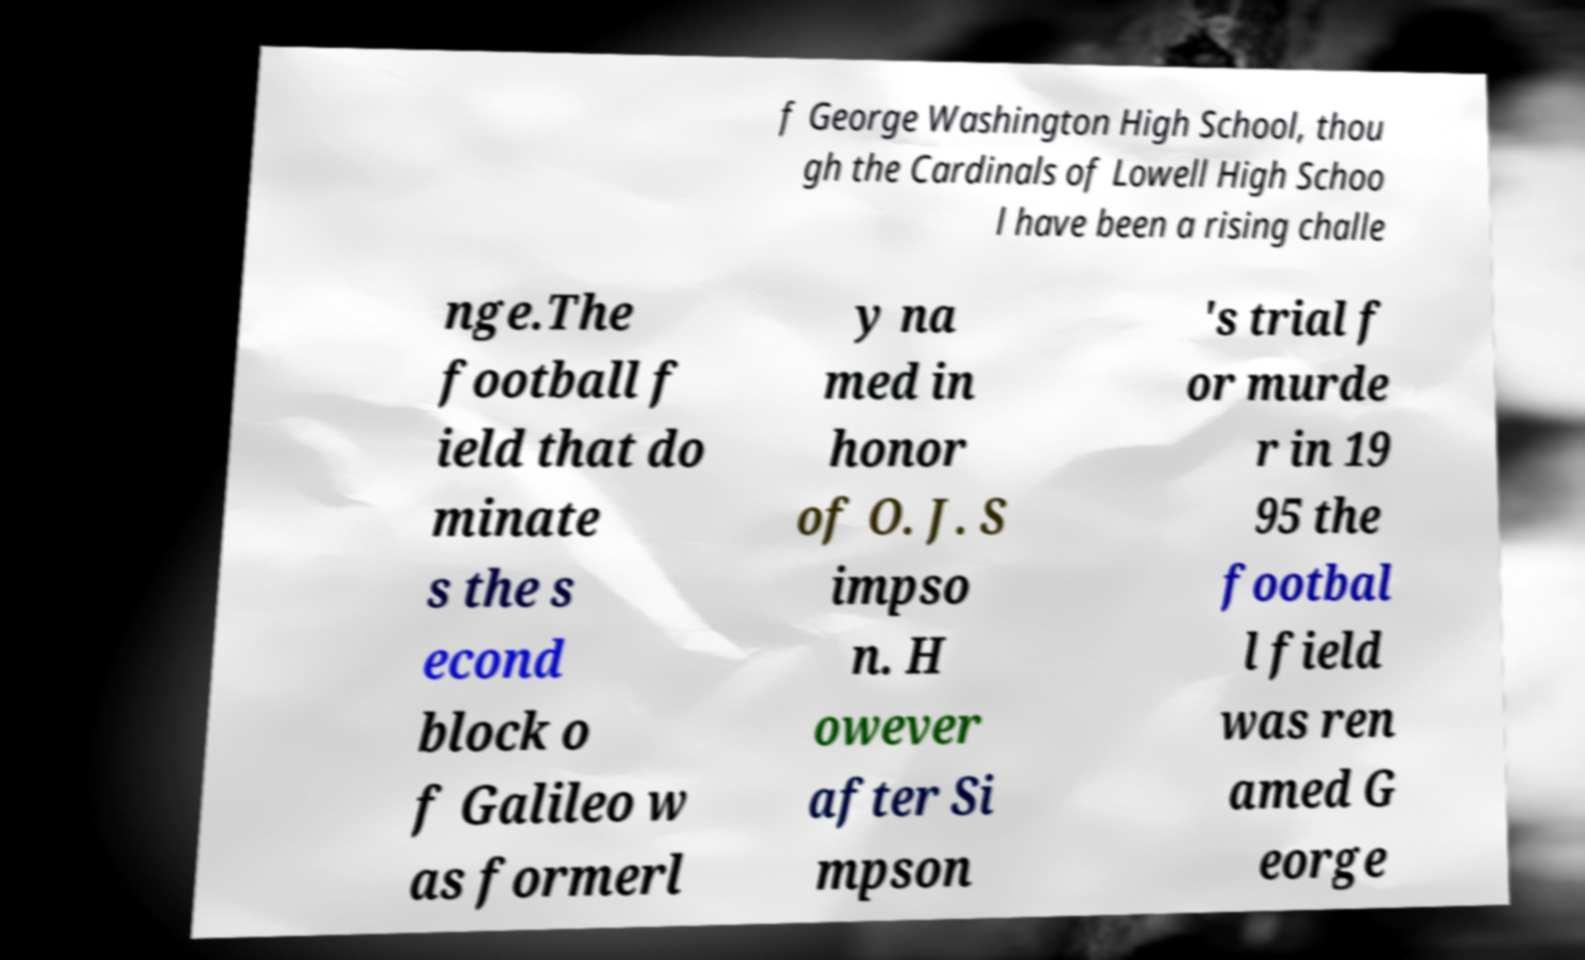Could you assist in decoding the text presented in this image and type it out clearly? f George Washington High School, thou gh the Cardinals of Lowell High Schoo l have been a rising challe nge.The football f ield that do minate s the s econd block o f Galileo w as formerl y na med in honor of O. J. S impso n. H owever after Si mpson 's trial f or murde r in 19 95 the footbal l field was ren amed G eorge 